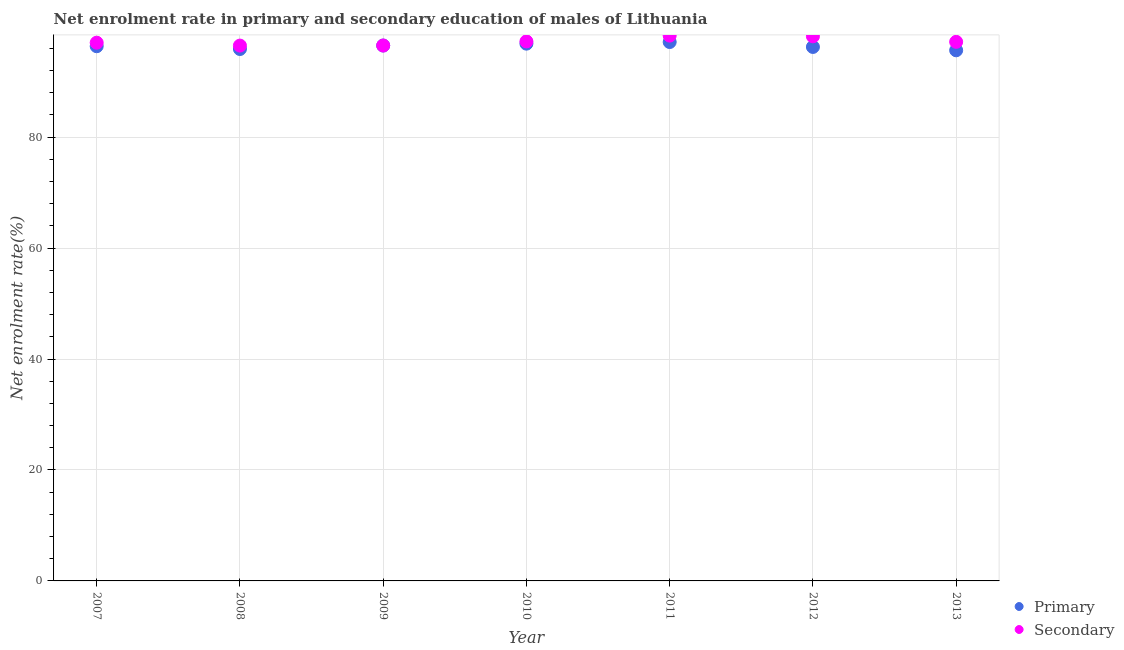What is the enrollment rate in primary education in 2013?
Ensure brevity in your answer.  95.66. Across all years, what is the maximum enrollment rate in primary education?
Give a very brief answer. 97.15. Across all years, what is the minimum enrollment rate in secondary education?
Give a very brief answer. 96.51. In which year was the enrollment rate in secondary education maximum?
Provide a succinct answer. 2011. In which year was the enrollment rate in secondary education minimum?
Offer a very short reply. 2008. What is the total enrollment rate in primary education in the graph?
Offer a terse response. 674.74. What is the difference between the enrollment rate in primary education in 2010 and that in 2011?
Keep it short and to the point. -0.29. What is the difference between the enrollment rate in primary education in 2010 and the enrollment rate in secondary education in 2013?
Make the answer very short. -0.33. What is the average enrollment rate in secondary education per year?
Ensure brevity in your answer.  97.28. In the year 2007, what is the difference between the enrollment rate in secondary education and enrollment rate in primary education?
Offer a terse response. 0.64. In how many years, is the enrollment rate in primary education greater than 8 %?
Give a very brief answer. 7. What is the ratio of the enrollment rate in secondary education in 2009 to that in 2010?
Provide a short and direct response. 0.99. Is the enrollment rate in secondary education in 2011 less than that in 2012?
Make the answer very short. No. Is the difference between the enrollment rate in secondary education in 2007 and 2011 greater than the difference between the enrollment rate in primary education in 2007 and 2011?
Provide a succinct answer. No. What is the difference between the highest and the second highest enrollment rate in primary education?
Make the answer very short. 0.29. What is the difference between the highest and the lowest enrollment rate in primary education?
Make the answer very short. 1.49. Is the enrollment rate in primary education strictly greater than the enrollment rate in secondary education over the years?
Provide a short and direct response. No. Is the enrollment rate in primary education strictly less than the enrollment rate in secondary education over the years?
Give a very brief answer. Yes. How many years are there in the graph?
Offer a terse response. 7. What is the difference between two consecutive major ticks on the Y-axis?
Make the answer very short. 20. Does the graph contain any zero values?
Keep it short and to the point. No. How are the legend labels stacked?
Your response must be concise. Vertical. What is the title of the graph?
Give a very brief answer. Net enrolment rate in primary and secondary education of males of Lithuania. Does "Investment" appear as one of the legend labels in the graph?
Your answer should be very brief. No. What is the label or title of the X-axis?
Make the answer very short. Year. What is the label or title of the Y-axis?
Provide a short and direct response. Net enrolment rate(%). What is the Net enrolment rate(%) in Primary in 2007?
Provide a short and direct response. 96.4. What is the Net enrolment rate(%) of Secondary in 2007?
Provide a succinct answer. 97.03. What is the Net enrolment rate(%) in Primary in 2008?
Keep it short and to the point. 95.89. What is the Net enrolment rate(%) of Secondary in 2008?
Provide a short and direct response. 96.51. What is the Net enrolment rate(%) in Primary in 2009?
Provide a short and direct response. 96.52. What is the Net enrolment rate(%) in Secondary in 2009?
Your answer should be very brief. 96.52. What is the Net enrolment rate(%) in Primary in 2010?
Ensure brevity in your answer.  96.86. What is the Net enrolment rate(%) of Secondary in 2010?
Your answer should be very brief. 97.26. What is the Net enrolment rate(%) in Primary in 2011?
Ensure brevity in your answer.  97.15. What is the Net enrolment rate(%) of Secondary in 2011?
Ensure brevity in your answer.  98.31. What is the Net enrolment rate(%) of Primary in 2012?
Your answer should be very brief. 96.26. What is the Net enrolment rate(%) in Secondary in 2012?
Your answer should be very brief. 98.18. What is the Net enrolment rate(%) in Primary in 2013?
Provide a short and direct response. 95.66. What is the Net enrolment rate(%) in Secondary in 2013?
Your answer should be very brief. 97.18. Across all years, what is the maximum Net enrolment rate(%) of Primary?
Your answer should be very brief. 97.15. Across all years, what is the maximum Net enrolment rate(%) of Secondary?
Your response must be concise. 98.31. Across all years, what is the minimum Net enrolment rate(%) of Primary?
Your response must be concise. 95.66. Across all years, what is the minimum Net enrolment rate(%) of Secondary?
Offer a terse response. 96.51. What is the total Net enrolment rate(%) of Primary in the graph?
Provide a short and direct response. 674.74. What is the total Net enrolment rate(%) of Secondary in the graph?
Offer a terse response. 680.99. What is the difference between the Net enrolment rate(%) of Primary in 2007 and that in 2008?
Your response must be concise. 0.5. What is the difference between the Net enrolment rate(%) of Secondary in 2007 and that in 2008?
Give a very brief answer. 0.52. What is the difference between the Net enrolment rate(%) in Primary in 2007 and that in 2009?
Your answer should be very brief. -0.12. What is the difference between the Net enrolment rate(%) in Secondary in 2007 and that in 2009?
Keep it short and to the point. 0.51. What is the difference between the Net enrolment rate(%) in Primary in 2007 and that in 2010?
Provide a succinct answer. -0.46. What is the difference between the Net enrolment rate(%) of Secondary in 2007 and that in 2010?
Your response must be concise. -0.23. What is the difference between the Net enrolment rate(%) of Primary in 2007 and that in 2011?
Give a very brief answer. -0.76. What is the difference between the Net enrolment rate(%) in Secondary in 2007 and that in 2011?
Keep it short and to the point. -1.28. What is the difference between the Net enrolment rate(%) in Primary in 2007 and that in 2012?
Offer a terse response. 0.13. What is the difference between the Net enrolment rate(%) in Secondary in 2007 and that in 2012?
Offer a terse response. -1.14. What is the difference between the Net enrolment rate(%) of Primary in 2007 and that in 2013?
Offer a terse response. 0.74. What is the difference between the Net enrolment rate(%) of Secondary in 2007 and that in 2013?
Make the answer very short. -0.15. What is the difference between the Net enrolment rate(%) in Primary in 2008 and that in 2009?
Give a very brief answer. -0.63. What is the difference between the Net enrolment rate(%) in Secondary in 2008 and that in 2009?
Ensure brevity in your answer.  -0.01. What is the difference between the Net enrolment rate(%) in Primary in 2008 and that in 2010?
Your answer should be very brief. -0.97. What is the difference between the Net enrolment rate(%) in Secondary in 2008 and that in 2010?
Make the answer very short. -0.75. What is the difference between the Net enrolment rate(%) in Primary in 2008 and that in 2011?
Your response must be concise. -1.26. What is the difference between the Net enrolment rate(%) of Secondary in 2008 and that in 2011?
Offer a very short reply. -1.8. What is the difference between the Net enrolment rate(%) of Primary in 2008 and that in 2012?
Make the answer very short. -0.37. What is the difference between the Net enrolment rate(%) of Secondary in 2008 and that in 2012?
Offer a terse response. -1.67. What is the difference between the Net enrolment rate(%) of Primary in 2008 and that in 2013?
Your answer should be compact. 0.23. What is the difference between the Net enrolment rate(%) of Secondary in 2008 and that in 2013?
Your answer should be very brief. -0.68. What is the difference between the Net enrolment rate(%) of Primary in 2009 and that in 2010?
Provide a short and direct response. -0.34. What is the difference between the Net enrolment rate(%) in Secondary in 2009 and that in 2010?
Provide a succinct answer. -0.74. What is the difference between the Net enrolment rate(%) in Primary in 2009 and that in 2011?
Your response must be concise. -0.63. What is the difference between the Net enrolment rate(%) of Secondary in 2009 and that in 2011?
Provide a short and direct response. -1.79. What is the difference between the Net enrolment rate(%) in Primary in 2009 and that in 2012?
Keep it short and to the point. 0.26. What is the difference between the Net enrolment rate(%) in Secondary in 2009 and that in 2012?
Make the answer very short. -1.66. What is the difference between the Net enrolment rate(%) of Primary in 2009 and that in 2013?
Offer a very short reply. 0.86. What is the difference between the Net enrolment rate(%) in Secondary in 2009 and that in 2013?
Your answer should be compact. -0.66. What is the difference between the Net enrolment rate(%) in Primary in 2010 and that in 2011?
Provide a short and direct response. -0.29. What is the difference between the Net enrolment rate(%) in Secondary in 2010 and that in 2011?
Offer a terse response. -1.05. What is the difference between the Net enrolment rate(%) of Primary in 2010 and that in 2012?
Make the answer very short. 0.59. What is the difference between the Net enrolment rate(%) of Secondary in 2010 and that in 2012?
Ensure brevity in your answer.  -0.92. What is the difference between the Net enrolment rate(%) of Primary in 2010 and that in 2013?
Provide a succinct answer. 1.2. What is the difference between the Net enrolment rate(%) in Secondary in 2010 and that in 2013?
Give a very brief answer. 0.08. What is the difference between the Net enrolment rate(%) in Primary in 2011 and that in 2012?
Give a very brief answer. 0.89. What is the difference between the Net enrolment rate(%) of Secondary in 2011 and that in 2012?
Your answer should be very brief. 0.13. What is the difference between the Net enrolment rate(%) of Primary in 2011 and that in 2013?
Offer a terse response. 1.49. What is the difference between the Net enrolment rate(%) of Secondary in 2011 and that in 2013?
Your response must be concise. 1.12. What is the difference between the Net enrolment rate(%) in Primary in 2012 and that in 2013?
Provide a succinct answer. 0.6. What is the difference between the Net enrolment rate(%) of Primary in 2007 and the Net enrolment rate(%) of Secondary in 2008?
Give a very brief answer. -0.11. What is the difference between the Net enrolment rate(%) of Primary in 2007 and the Net enrolment rate(%) of Secondary in 2009?
Keep it short and to the point. -0.12. What is the difference between the Net enrolment rate(%) in Primary in 2007 and the Net enrolment rate(%) in Secondary in 2010?
Your response must be concise. -0.87. What is the difference between the Net enrolment rate(%) in Primary in 2007 and the Net enrolment rate(%) in Secondary in 2011?
Provide a short and direct response. -1.91. What is the difference between the Net enrolment rate(%) of Primary in 2007 and the Net enrolment rate(%) of Secondary in 2012?
Provide a short and direct response. -1.78. What is the difference between the Net enrolment rate(%) of Primary in 2007 and the Net enrolment rate(%) of Secondary in 2013?
Make the answer very short. -0.79. What is the difference between the Net enrolment rate(%) of Primary in 2008 and the Net enrolment rate(%) of Secondary in 2009?
Keep it short and to the point. -0.63. What is the difference between the Net enrolment rate(%) in Primary in 2008 and the Net enrolment rate(%) in Secondary in 2010?
Give a very brief answer. -1.37. What is the difference between the Net enrolment rate(%) in Primary in 2008 and the Net enrolment rate(%) in Secondary in 2011?
Keep it short and to the point. -2.42. What is the difference between the Net enrolment rate(%) in Primary in 2008 and the Net enrolment rate(%) in Secondary in 2012?
Give a very brief answer. -2.28. What is the difference between the Net enrolment rate(%) of Primary in 2008 and the Net enrolment rate(%) of Secondary in 2013?
Ensure brevity in your answer.  -1.29. What is the difference between the Net enrolment rate(%) in Primary in 2009 and the Net enrolment rate(%) in Secondary in 2010?
Offer a terse response. -0.74. What is the difference between the Net enrolment rate(%) in Primary in 2009 and the Net enrolment rate(%) in Secondary in 2011?
Offer a terse response. -1.79. What is the difference between the Net enrolment rate(%) in Primary in 2009 and the Net enrolment rate(%) in Secondary in 2012?
Offer a terse response. -1.66. What is the difference between the Net enrolment rate(%) of Primary in 2009 and the Net enrolment rate(%) of Secondary in 2013?
Make the answer very short. -0.66. What is the difference between the Net enrolment rate(%) of Primary in 2010 and the Net enrolment rate(%) of Secondary in 2011?
Your answer should be very brief. -1.45. What is the difference between the Net enrolment rate(%) in Primary in 2010 and the Net enrolment rate(%) in Secondary in 2012?
Ensure brevity in your answer.  -1.32. What is the difference between the Net enrolment rate(%) in Primary in 2010 and the Net enrolment rate(%) in Secondary in 2013?
Offer a terse response. -0.33. What is the difference between the Net enrolment rate(%) in Primary in 2011 and the Net enrolment rate(%) in Secondary in 2012?
Ensure brevity in your answer.  -1.03. What is the difference between the Net enrolment rate(%) of Primary in 2011 and the Net enrolment rate(%) of Secondary in 2013?
Your response must be concise. -0.03. What is the difference between the Net enrolment rate(%) of Primary in 2012 and the Net enrolment rate(%) of Secondary in 2013?
Your answer should be very brief. -0.92. What is the average Net enrolment rate(%) in Primary per year?
Make the answer very short. 96.39. What is the average Net enrolment rate(%) of Secondary per year?
Your answer should be very brief. 97.28. In the year 2007, what is the difference between the Net enrolment rate(%) of Primary and Net enrolment rate(%) of Secondary?
Your response must be concise. -0.64. In the year 2008, what is the difference between the Net enrolment rate(%) of Primary and Net enrolment rate(%) of Secondary?
Make the answer very short. -0.62. In the year 2009, what is the difference between the Net enrolment rate(%) in Primary and Net enrolment rate(%) in Secondary?
Ensure brevity in your answer.  -0. In the year 2010, what is the difference between the Net enrolment rate(%) of Primary and Net enrolment rate(%) of Secondary?
Keep it short and to the point. -0.4. In the year 2011, what is the difference between the Net enrolment rate(%) in Primary and Net enrolment rate(%) in Secondary?
Offer a very short reply. -1.16. In the year 2012, what is the difference between the Net enrolment rate(%) of Primary and Net enrolment rate(%) of Secondary?
Your answer should be compact. -1.91. In the year 2013, what is the difference between the Net enrolment rate(%) of Primary and Net enrolment rate(%) of Secondary?
Make the answer very short. -1.52. What is the ratio of the Net enrolment rate(%) of Primary in 2007 to that in 2008?
Provide a short and direct response. 1.01. What is the ratio of the Net enrolment rate(%) in Secondary in 2007 to that in 2008?
Your answer should be compact. 1.01. What is the ratio of the Net enrolment rate(%) of Secondary in 2007 to that in 2009?
Your answer should be very brief. 1.01. What is the ratio of the Net enrolment rate(%) of Primary in 2007 to that in 2010?
Your answer should be compact. 1. What is the ratio of the Net enrolment rate(%) in Primary in 2007 to that in 2011?
Provide a short and direct response. 0.99. What is the ratio of the Net enrolment rate(%) in Secondary in 2007 to that in 2011?
Offer a very short reply. 0.99. What is the ratio of the Net enrolment rate(%) of Secondary in 2007 to that in 2012?
Make the answer very short. 0.99. What is the ratio of the Net enrolment rate(%) of Primary in 2007 to that in 2013?
Offer a very short reply. 1.01. What is the ratio of the Net enrolment rate(%) in Secondary in 2007 to that in 2013?
Your answer should be compact. 1. What is the ratio of the Net enrolment rate(%) in Secondary in 2008 to that in 2009?
Offer a terse response. 1. What is the ratio of the Net enrolment rate(%) in Secondary in 2008 to that in 2010?
Your answer should be compact. 0.99. What is the ratio of the Net enrolment rate(%) in Primary in 2008 to that in 2011?
Your answer should be very brief. 0.99. What is the ratio of the Net enrolment rate(%) in Secondary in 2008 to that in 2011?
Your response must be concise. 0.98. What is the ratio of the Net enrolment rate(%) in Secondary in 2008 to that in 2012?
Keep it short and to the point. 0.98. What is the ratio of the Net enrolment rate(%) of Primary in 2008 to that in 2013?
Your answer should be very brief. 1. What is the ratio of the Net enrolment rate(%) of Secondary in 2008 to that in 2013?
Provide a succinct answer. 0.99. What is the ratio of the Net enrolment rate(%) in Primary in 2009 to that in 2010?
Ensure brevity in your answer.  1. What is the ratio of the Net enrolment rate(%) of Secondary in 2009 to that in 2011?
Keep it short and to the point. 0.98. What is the ratio of the Net enrolment rate(%) in Primary in 2009 to that in 2012?
Offer a very short reply. 1. What is the ratio of the Net enrolment rate(%) of Secondary in 2009 to that in 2012?
Provide a succinct answer. 0.98. What is the ratio of the Net enrolment rate(%) of Secondary in 2010 to that in 2011?
Your answer should be compact. 0.99. What is the ratio of the Net enrolment rate(%) of Primary in 2010 to that in 2012?
Keep it short and to the point. 1.01. What is the ratio of the Net enrolment rate(%) in Primary in 2010 to that in 2013?
Offer a very short reply. 1.01. What is the ratio of the Net enrolment rate(%) of Primary in 2011 to that in 2012?
Provide a short and direct response. 1.01. What is the ratio of the Net enrolment rate(%) of Secondary in 2011 to that in 2012?
Provide a short and direct response. 1. What is the ratio of the Net enrolment rate(%) in Primary in 2011 to that in 2013?
Ensure brevity in your answer.  1.02. What is the ratio of the Net enrolment rate(%) in Secondary in 2011 to that in 2013?
Provide a succinct answer. 1.01. What is the ratio of the Net enrolment rate(%) of Primary in 2012 to that in 2013?
Keep it short and to the point. 1.01. What is the ratio of the Net enrolment rate(%) of Secondary in 2012 to that in 2013?
Your answer should be very brief. 1.01. What is the difference between the highest and the second highest Net enrolment rate(%) in Primary?
Make the answer very short. 0.29. What is the difference between the highest and the second highest Net enrolment rate(%) of Secondary?
Your answer should be very brief. 0.13. What is the difference between the highest and the lowest Net enrolment rate(%) in Primary?
Provide a short and direct response. 1.49. What is the difference between the highest and the lowest Net enrolment rate(%) of Secondary?
Your response must be concise. 1.8. 